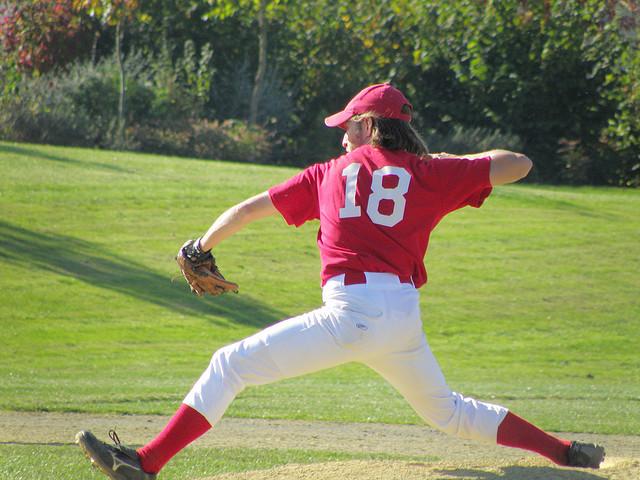What type of sport are the men playing?
Give a very brief answer. Baseball. What number is on the person's Jersey?
Give a very brief answer. 18. What is the man doing?
Concise answer only. Pitching. What action is this person performing?
Answer briefly. Pitching. 